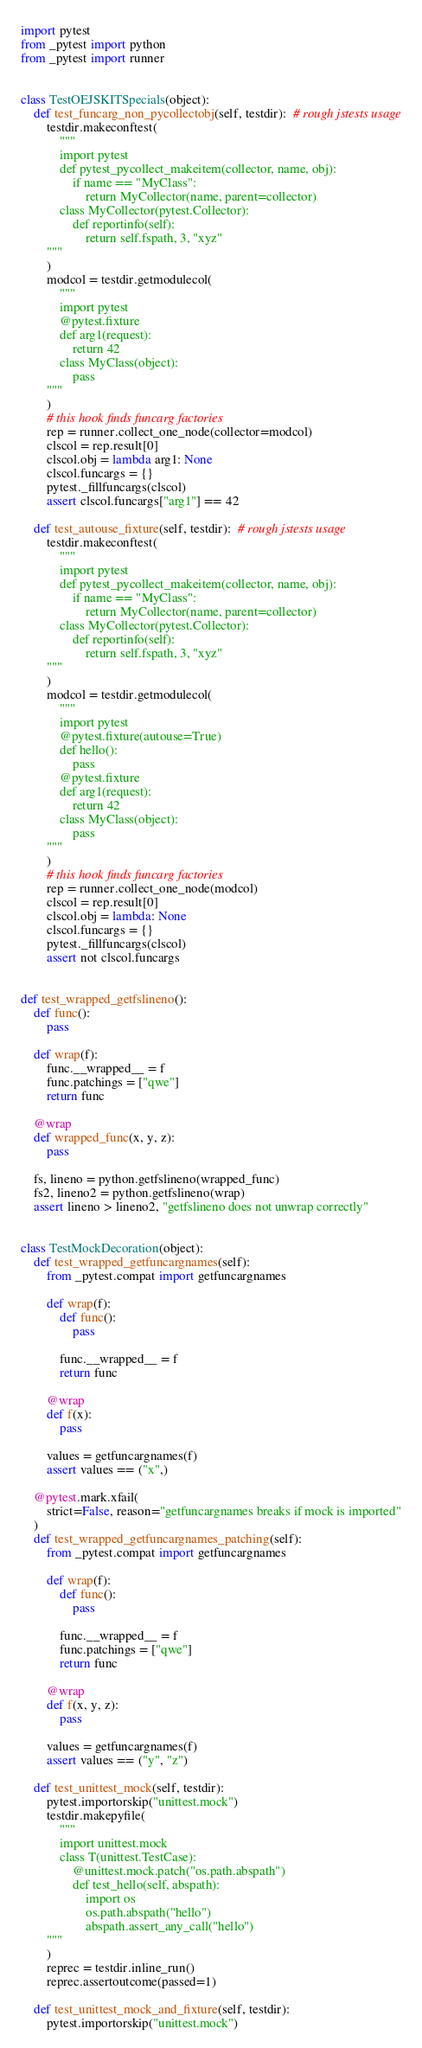<code> <loc_0><loc_0><loc_500><loc_500><_Python_>import pytest
from _pytest import python
from _pytest import runner


class TestOEJSKITSpecials(object):
    def test_funcarg_non_pycollectobj(self, testdir):  # rough jstests usage
        testdir.makeconftest(
            """
            import pytest
            def pytest_pycollect_makeitem(collector, name, obj):
                if name == "MyClass":
                    return MyCollector(name, parent=collector)
            class MyCollector(pytest.Collector):
                def reportinfo(self):
                    return self.fspath, 3, "xyz"
        """
        )
        modcol = testdir.getmodulecol(
            """
            import pytest
            @pytest.fixture
            def arg1(request):
                return 42
            class MyClass(object):
                pass
        """
        )
        # this hook finds funcarg factories
        rep = runner.collect_one_node(collector=modcol)
        clscol = rep.result[0]
        clscol.obj = lambda arg1: None
        clscol.funcargs = {}
        pytest._fillfuncargs(clscol)
        assert clscol.funcargs["arg1"] == 42

    def test_autouse_fixture(self, testdir):  # rough jstests usage
        testdir.makeconftest(
            """
            import pytest
            def pytest_pycollect_makeitem(collector, name, obj):
                if name == "MyClass":
                    return MyCollector(name, parent=collector)
            class MyCollector(pytest.Collector):
                def reportinfo(self):
                    return self.fspath, 3, "xyz"
        """
        )
        modcol = testdir.getmodulecol(
            """
            import pytest
            @pytest.fixture(autouse=True)
            def hello():
                pass
            @pytest.fixture
            def arg1(request):
                return 42
            class MyClass(object):
                pass
        """
        )
        # this hook finds funcarg factories
        rep = runner.collect_one_node(modcol)
        clscol = rep.result[0]
        clscol.obj = lambda: None
        clscol.funcargs = {}
        pytest._fillfuncargs(clscol)
        assert not clscol.funcargs


def test_wrapped_getfslineno():
    def func():
        pass

    def wrap(f):
        func.__wrapped__ = f
        func.patchings = ["qwe"]
        return func

    @wrap
    def wrapped_func(x, y, z):
        pass

    fs, lineno = python.getfslineno(wrapped_func)
    fs2, lineno2 = python.getfslineno(wrap)
    assert lineno > lineno2, "getfslineno does not unwrap correctly"


class TestMockDecoration(object):
    def test_wrapped_getfuncargnames(self):
        from _pytest.compat import getfuncargnames

        def wrap(f):
            def func():
                pass

            func.__wrapped__ = f
            return func

        @wrap
        def f(x):
            pass

        values = getfuncargnames(f)
        assert values == ("x",)

    @pytest.mark.xfail(
        strict=False, reason="getfuncargnames breaks if mock is imported"
    )
    def test_wrapped_getfuncargnames_patching(self):
        from _pytest.compat import getfuncargnames

        def wrap(f):
            def func():
                pass

            func.__wrapped__ = f
            func.patchings = ["qwe"]
            return func

        @wrap
        def f(x, y, z):
            pass

        values = getfuncargnames(f)
        assert values == ("y", "z")

    def test_unittest_mock(self, testdir):
        pytest.importorskip("unittest.mock")
        testdir.makepyfile(
            """
            import unittest.mock
            class T(unittest.TestCase):
                @unittest.mock.patch("os.path.abspath")
                def test_hello(self, abspath):
                    import os
                    os.path.abspath("hello")
                    abspath.assert_any_call("hello")
        """
        )
        reprec = testdir.inline_run()
        reprec.assertoutcome(passed=1)

    def test_unittest_mock_and_fixture(self, testdir):
        pytest.importorskip("unittest.mock")</code> 